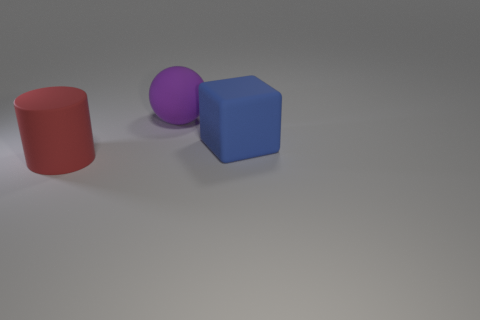What number of shiny objects are either cubes or blue cylinders?
Ensure brevity in your answer.  0. Is there a big rubber block that is to the left of the object on the right side of the purple ball?
Offer a very short reply. No. What number of red rubber things are in front of the large blue matte object?
Provide a short and direct response. 1. There is a rubber thing that is both behind the large red cylinder and in front of the purple thing; what is its shape?
Offer a terse response. Cube. How many matte spheres are there?
Your response must be concise. 1. Is the shape of the rubber thing that is in front of the blue matte cube the same as  the big purple object?
Give a very brief answer. No. The large rubber thing that is to the left of the purple thing is what color?
Make the answer very short. Red. What number of other things are there of the same size as the red rubber cylinder?
Offer a terse response. 2. Is there anything else that has the same shape as the blue rubber thing?
Keep it short and to the point. No. Are there the same number of big red cylinders that are in front of the sphere and big rubber balls?
Provide a succinct answer. Yes. 